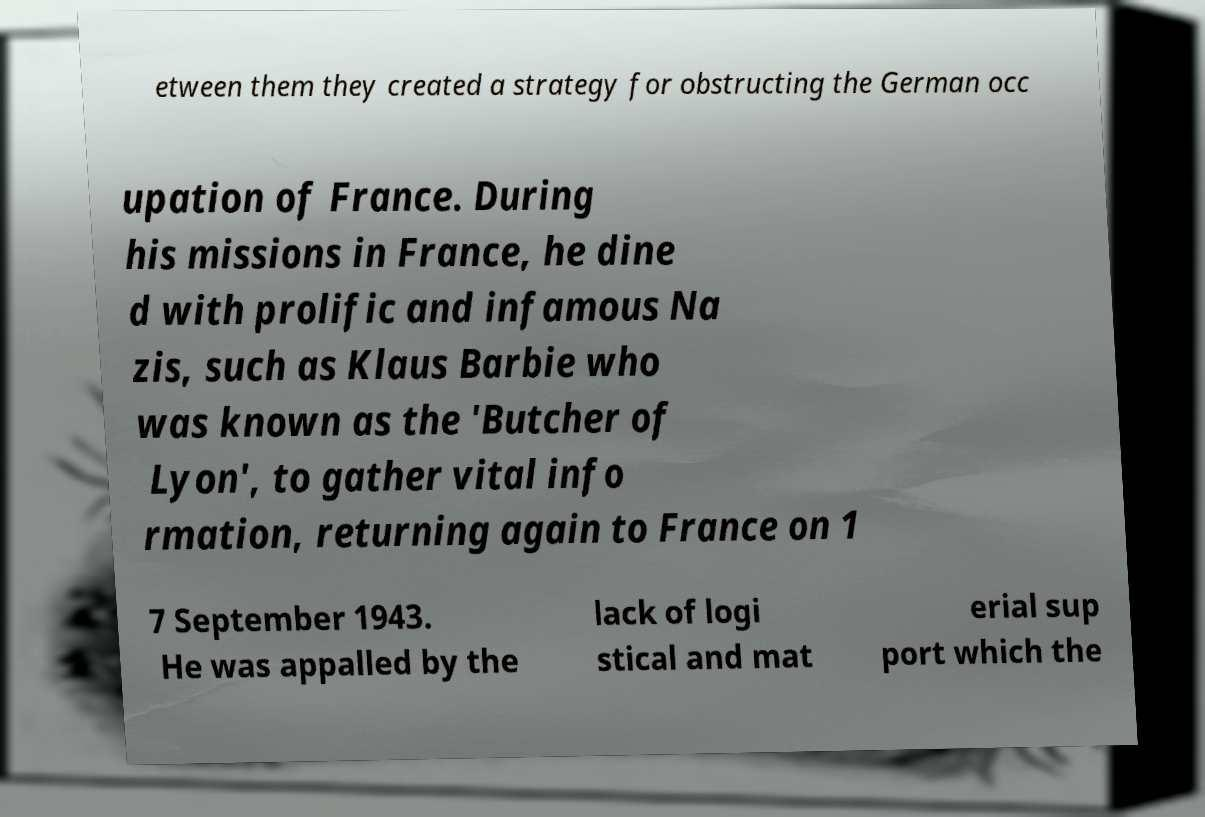Could you assist in decoding the text presented in this image and type it out clearly? etween them they created a strategy for obstructing the German occ upation of France. During his missions in France, he dine d with prolific and infamous Na zis, such as Klaus Barbie who was known as the 'Butcher of Lyon', to gather vital info rmation, returning again to France on 1 7 September 1943. He was appalled by the lack of logi stical and mat erial sup port which the 